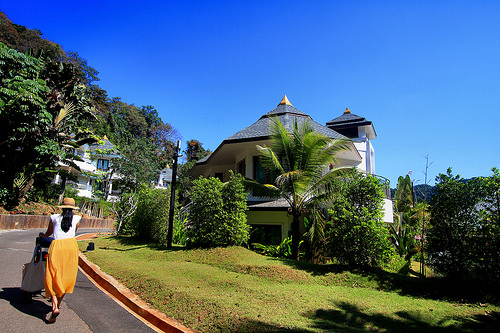<image>
Can you confirm if the tree is behind the house? No. The tree is not behind the house. From this viewpoint, the tree appears to be positioned elsewhere in the scene. 